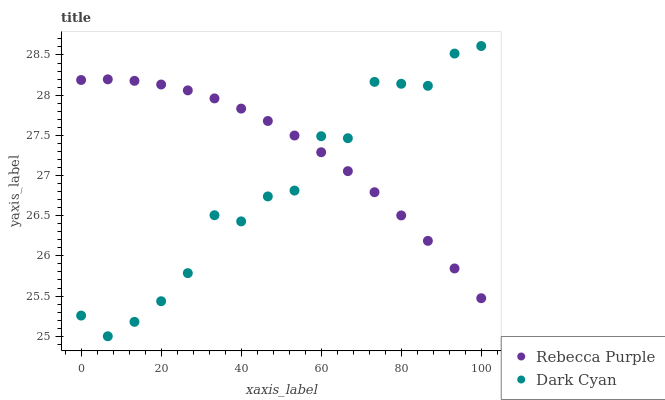Does Dark Cyan have the minimum area under the curve?
Answer yes or no. Yes. Does Rebecca Purple have the maximum area under the curve?
Answer yes or no. Yes. Does Rebecca Purple have the minimum area under the curve?
Answer yes or no. No. Is Rebecca Purple the smoothest?
Answer yes or no. Yes. Is Dark Cyan the roughest?
Answer yes or no. Yes. Is Rebecca Purple the roughest?
Answer yes or no. No. Does Dark Cyan have the lowest value?
Answer yes or no. Yes. Does Rebecca Purple have the lowest value?
Answer yes or no. No. Does Dark Cyan have the highest value?
Answer yes or no. Yes. Does Rebecca Purple have the highest value?
Answer yes or no. No. Does Rebecca Purple intersect Dark Cyan?
Answer yes or no. Yes. Is Rebecca Purple less than Dark Cyan?
Answer yes or no. No. Is Rebecca Purple greater than Dark Cyan?
Answer yes or no. No. 